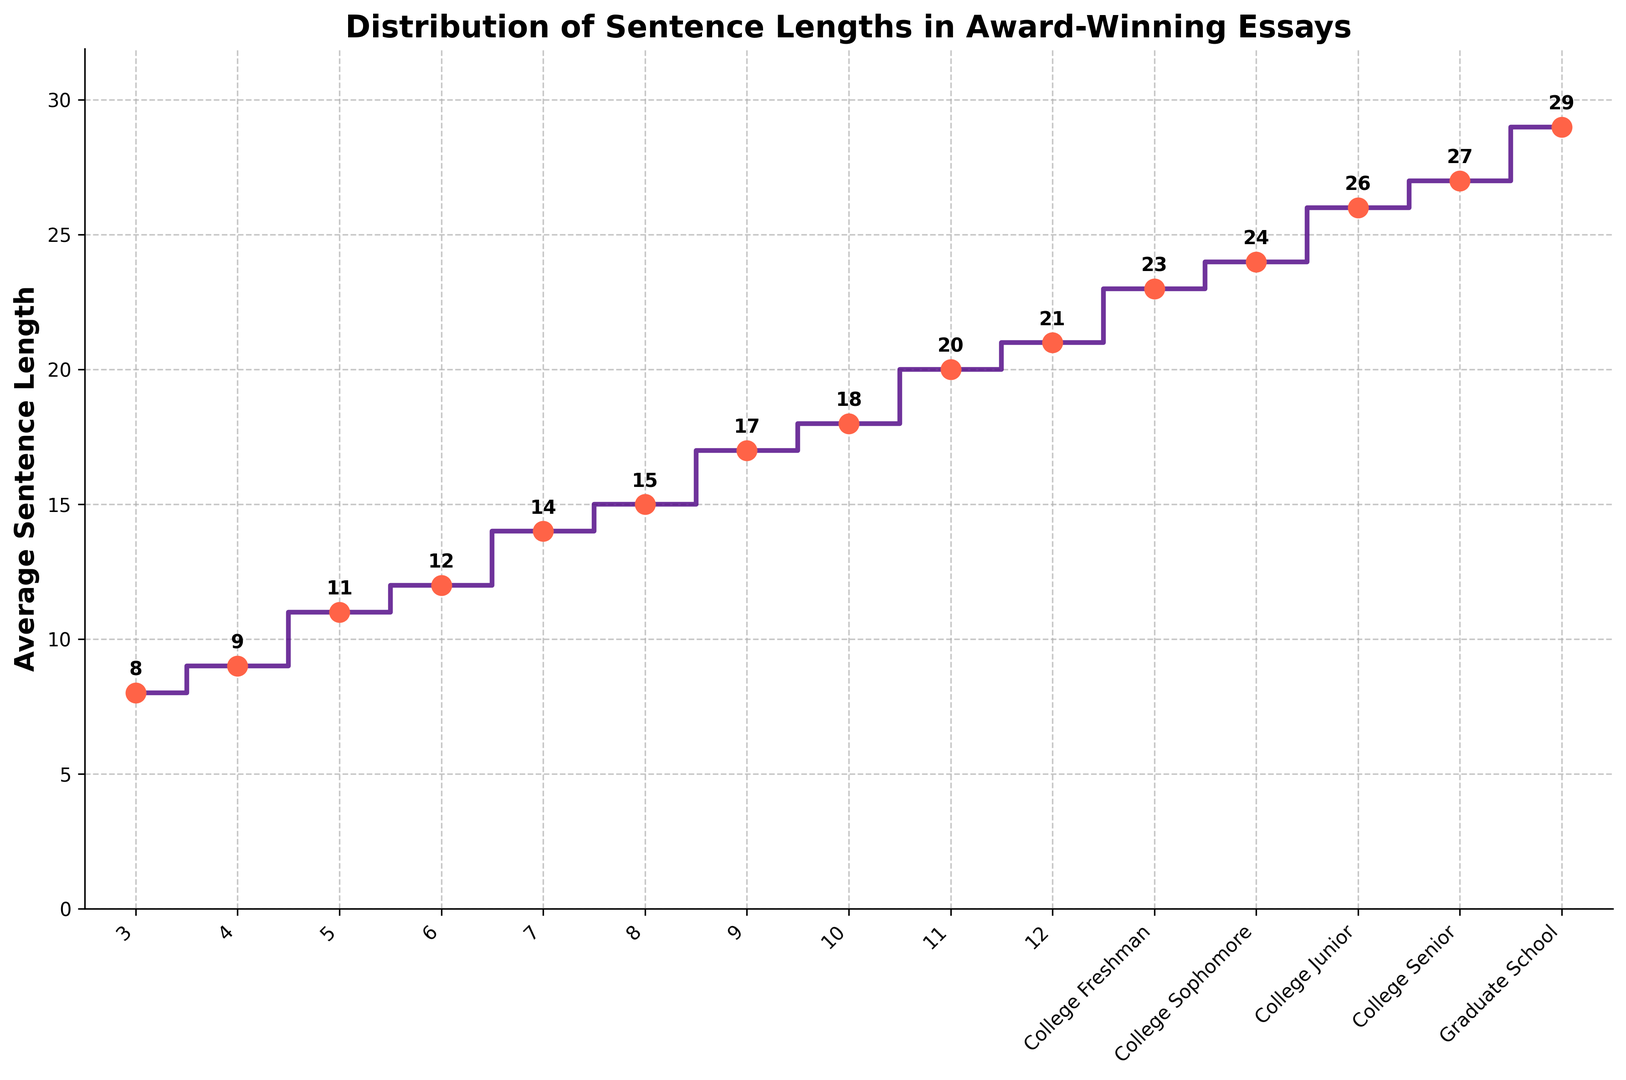Which grade level has the highest average sentence length? By looking at the figure, we can see the highest point on the y-axis corresponds to Graduate School, which has an average sentence length of 29.
Answer: Graduate School What is the increase in average sentence length from Grade 3 to Grade 6? The average sentence length for Grade 3 is 8, and for Grade 6, it is 12. Subtracting these values gives 12 - 8 = 4.
Answer: 4 How does the average sentence length for College Senior compare to College Freshman? The average sentence length for College Senior is 27, whereas for College Freshman, it is 23. Subtracting these values gives 27 - 23 = 4.
Answer: College Senior has an average sentence length that is 4 longer than College Freshman What is the average sentence length for grades 8 through 12? The average sentence lengths are 15, 17, 18, 20, and 21 for grades 8 through 12, respectively. Summing these values gives 15 + 17 + 18 + 20 + 21 = 91. Since there are 5 grades, we divide by 5, so 91 / 5 = 18.2.
Answer: 18.2 Is there any grade level where the average sentence length is 20 or more but less than 25? By looking at the plotted points, grades 11 (20), College Freshman (23), and College Sophomore (24) fall into this range of average sentence lengths.
Answer: Yes, grades 11, College Freshman, and College Sophomore Describe the general trend of the average sentence length as grade level increases. Observing the plotted points shows a generally increasing trend in average sentence length. Starting from lower values at elementary grade levels and moving to higher values in higher education levels.
Answer: The average sentence length increases as grade level increases By how much does the average sentence length increase from College Junior to Graduate School? The average sentence lengths are 26 for College Junior and 29 for Graduate School. Subtracting these values gives 29 - 26 = 3.
Answer: 3 What is the difference in average sentence length between Grade 7 and College Senior? The average sentence lengths are 14 for Grade 7 and 27 for College Senior. Subtracting these values gives 27 - 14 = 13.
Answer: 13 